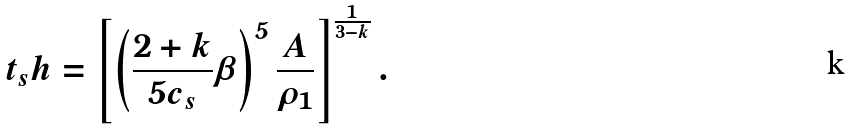<formula> <loc_0><loc_0><loc_500><loc_500>t _ { s } h = \left [ \left ( \frac { 2 + k } { 5 c _ { s } } \beta \right ) ^ { 5 } \frac { A } { \rho _ { 1 } } \right ] ^ { \frac { 1 } { 3 - k } } .</formula> 